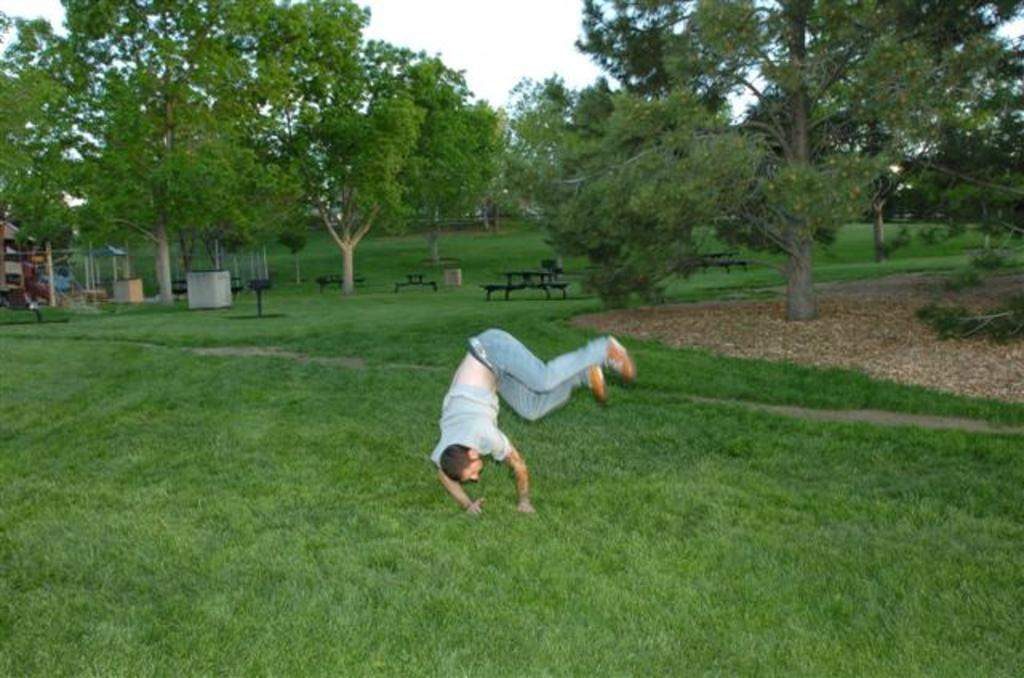Who is present in the image? There is a man in the image. What is the man's location in the image? The man is on the grass. What can be seen in the background of the image? There are trees, benches, and metal rods in the background of the image. What grade did the man receive for his suit in the image? There is no mention of a suit or any grading system in the image. The man is simply on the grass, and there are trees, benches, and metal rods in the background. 